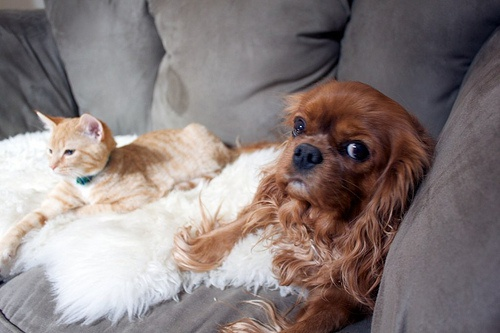Describe the objects in this image and their specific colors. I can see couch in gray, darkgray, and black tones, dog in gray, white, maroon, and black tones, and cat in gray, lightgray, and tan tones in this image. 